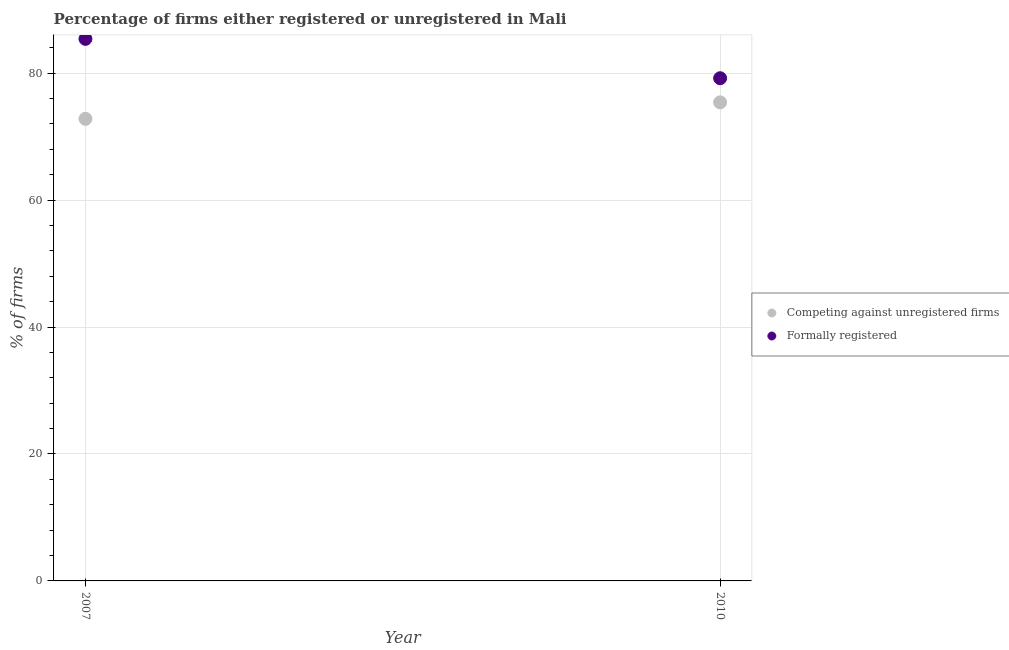What is the percentage of registered firms in 2010?
Offer a very short reply. 75.4. Across all years, what is the maximum percentage of formally registered firms?
Your answer should be very brief. 85.4. Across all years, what is the minimum percentage of formally registered firms?
Keep it short and to the point. 79.2. In which year was the percentage of registered firms minimum?
Give a very brief answer. 2007. What is the total percentage of formally registered firms in the graph?
Offer a terse response. 164.6. What is the difference between the percentage of registered firms in 2007 and that in 2010?
Provide a short and direct response. -2.6. What is the difference between the percentage of registered firms in 2007 and the percentage of formally registered firms in 2010?
Ensure brevity in your answer.  -6.4. What is the average percentage of formally registered firms per year?
Offer a very short reply. 82.3. In the year 2010, what is the difference between the percentage of registered firms and percentage of formally registered firms?
Your answer should be compact. -3.8. In how many years, is the percentage of registered firms greater than 32 %?
Your answer should be compact. 2. What is the ratio of the percentage of registered firms in 2007 to that in 2010?
Ensure brevity in your answer.  0.97. In how many years, is the percentage of registered firms greater than the average percentage of registered firms taken over all years?
Provide a succinct answer. 1. Does the percentage of registered firms monotonically increase over the years?
Your answer should be very brief. Yes. Is the percentage of formally registered firms strictly less than the percentage of registered firms over the years?
Give a very brief answer. No. How many years are there in the graph?
Your answer should be compact. 2. What is the difference between two consecutive major ticks on the Y-axis?
Your response must be concise. 20. Does the graph contain any zero values?
Provide a succinct answer. No. Does the graph contain grids?
Your answer should be compact. Yes. Where does the legend appear in the graph?
Offer a terse response. Center right. How many legend labels are there?
Provide a succinct answer. 2. What is the title of the graph?
Your response must be concise. Percentage of firms either registered or unregistered in Mali. What is the label or title of the Y-axis?
Ensure brevity in your answer.  % of firms. What is the % of firms in Competing against unregistered firms in 2007?
Your answer should be very brief. 72.8. What is the % of firms of Formally registered in 2007?
Give a very brief answer. 85.4. What is the % of firms of Competing against unregistered firms in 2010?
Keep it short and to the point. 75.4. What is the % of firms in Formally registered in 2010?
Offer a terse response. 79.2. Across all years, what is the maximum % of firms of Competing against unregistered firms?
Provide a short and direct response. 75.4. Across all years, what is the maximum % of firms in Formally registered?
Your answer should be compact. 85.4. Across all years, what is the minimum % of firms of Competing against unregistered firms?
Keep it short and to the point. 72.8. Across all years, what is the minimum % of firms of Formally registered?
Give a very brief answer. 79.2. What is the total % of firms of Competing against unregistered firms in the graph?
Provide a short and direct response. 148.2. What is the total % of firms in Formally registered in the graph?
Keep it short and to the point. 164.6. What is the difference between the % of firms of Competing against unregistered firms in 2007 and that in 2010?
Offer a terse response. -2.6. What is the difference between the % of firms of Formally registered in 2007 and that in 2010?
Offer a very short reply. 6.2. What is the difference between the % of firms of Competing against unregistered firms in 2007 and the % of firms of Formally registered in 2010?
Ensure brevity in your answer.  -6.4. What is the average % of firms of Competing against unregistered firms per year?
Your response must be concise. 74.1. What is the average % of firms in Formally registered per year?
Provide a short and direct response. 82.3. What is the ratio of the % of firms of Competing against unregistered firms in 2007 to that in 2010?
Your answer should be very brief. 0.97. What is the ratio of the % of firms of Formally registered in 2007 to that in 2010?
Offer a terse response. 1.08. What is the difference between the highest and the lowest % of firms of Competing against unregistered firms?
Provide a succinct answer. 2.6. 